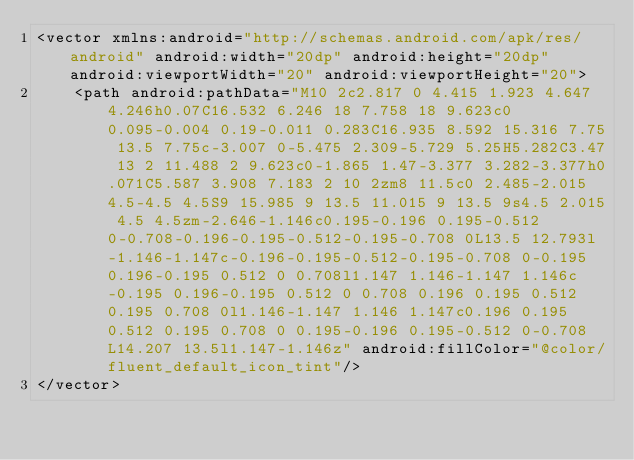<code> <loc_0><loc_0><loc_500><loc_500><_XML_><vector xmlns:android="http://schemas.android.com/apk/res/android" android:width="20dp" android:height="20dp" android:viewportWidth="20" android:viewportHeight="20">
    <path android:pathData="M10 2c2.817 0 4.415 1.923 4.647 4.246h0.07C16.532 6.246 18 7.758 18 9.623c0 0.095-0.004 0.19-0.011 0.283C16.935 8.592 15.316 7.75 13.5 7.75c-3.007 0-5.475 2.309-5.729 5.25H5.282C3.47 13 2 11.488 2 9.623c0-1.865 1.47-3.377 3.282-3.377h0.071C5.587 3.908 7.183 2 10 2zm8 11.5c0 2.485-2.015 4.5-4.5 4.5S9 15.985 9 13.5 11.015 9 13.5 9s4.5 2.015 4.5 4.5zm-2.646-1.146c0.195-0.196 0.195-0.512 0-0.708-0.196-0.195-0.512-0.195-0.708 0L13.5 12.793l-1.146-1.147c-0.196-0.195-0.512-0.195-0.708 0-0.195 0.196-0.195 0.512 0 0.708l1.147 1.146-1.147 1.146c-0.195 0.196-0.195 0.512 0 0.708 0.196 0.195 0.512 0.195 0.708 0l1.146-1.147 1.146 1.147c0.196 0.195 0.512 0.195 0.708 0 0.195-0.196 0.195-0.512 0-0.708L14.207 13.5l1.147-1.146z" android:fillColor="@color/fluent_default_icon_tint"/>
</vector>
</code> 